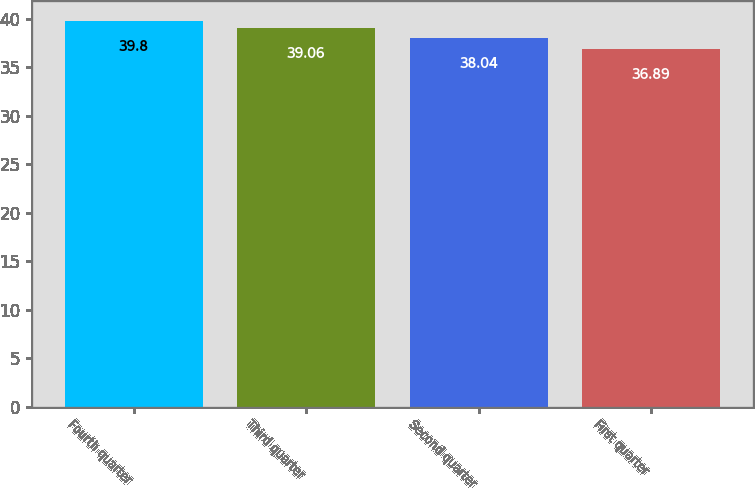Convert chart to OTSL. <chart><loc_0><loc_0><loc_500><loc_500><bar_chart><fcel>Fourth quarter<fcel>Third quarter<fcel>Second quarter<fcel>First quarter<nl><fcel>39.8<fcel>39.06<fcel>38.04<fcel>36.89<nl></chart> 